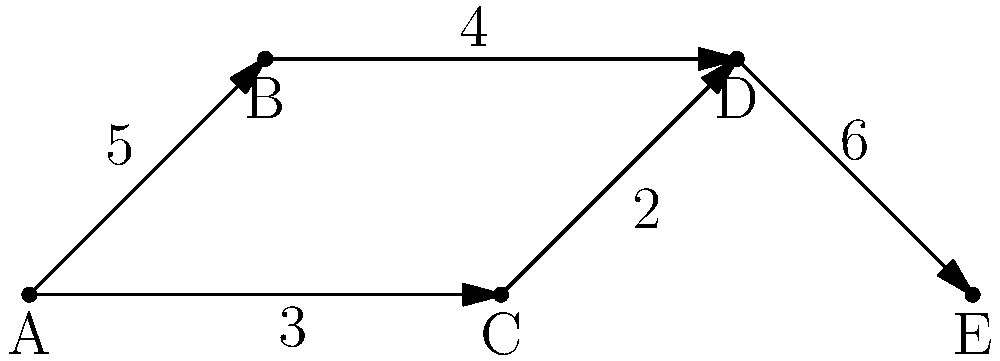In a high-profile case, you've obtained call logs for five suspects (A, B, C, D, and E). The network graph shows the communication patterns between them, with arrows indicating the direction of calls and numbers representing the call frequency. Which suspect appears to be the central figure in this communication network, and how many total calls did they make or receive? To determine the central figure and their total call count, we need to analyze the network graph step-by-step:

1. Identify each suspect's connections:
   A: connected to B and C
   B: connected to A and D
   C: connected to A and D
   D: connected to B, C, and E
   E: connected to D

2. Count the number of connections:
   A: 2 connections
   B: 2 connections
   C: 2 connections
   D: 3 connections
   E: 1 connection

3. Suspect D has the most connections (3), making them the central figure in the network.

4. Calculate D's total calls:
   - Calls from B to D: 4
   - Calls from C to D: 2
   - Calls from D to E: 6

5. Sum up D's total calls: 4 + 2 + 6 = 12

Therefore, suspect D is the central figure in the communication network, with a total of 12 calls made or received.
Answer: Suspect D, 12 calls 